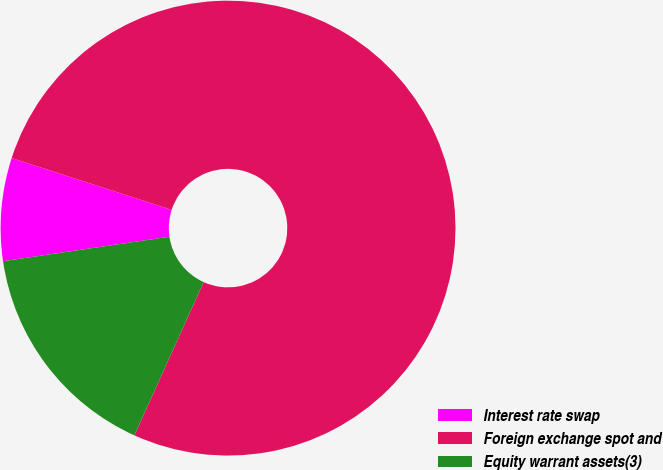<chart> <loc_0><loc_0><loc_500><loc_500><pie_chart><fcel>Interest rate swap<fcel>Foreign exchange spot and<fcel>Equity warrant assets(3)<nl><fcel>7.31%<fcel>76.78%<fcel>15.92%<nl></chart> 